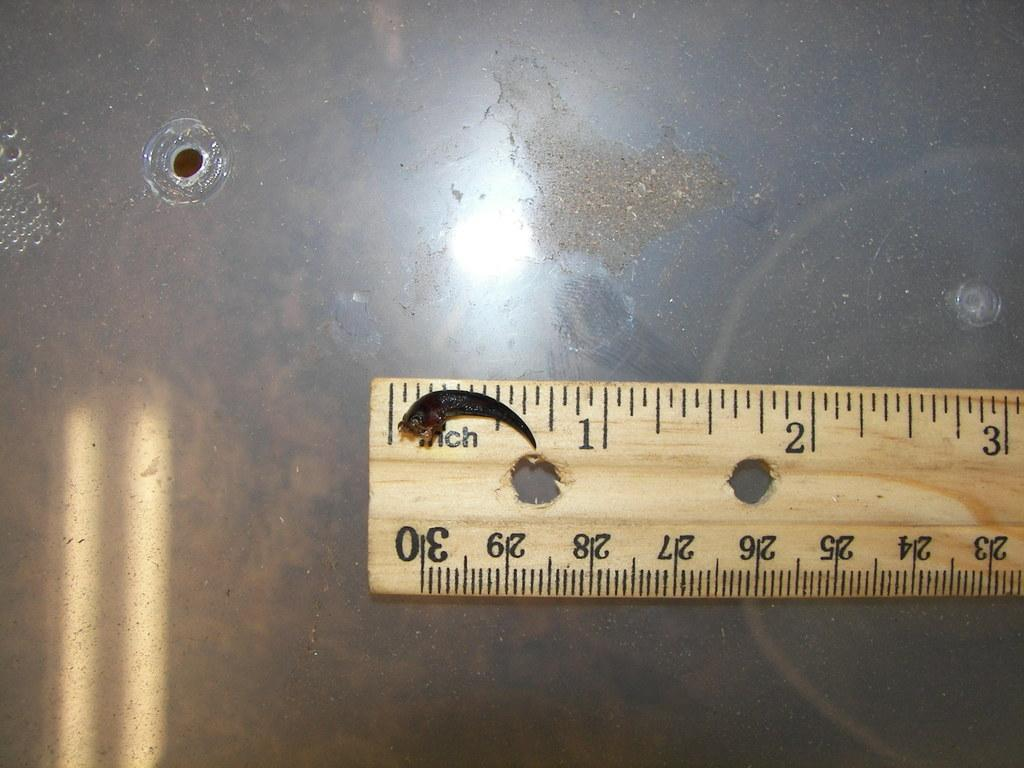<image>
Describe the image concisely. A small creature is being measured on a ruler stick. 